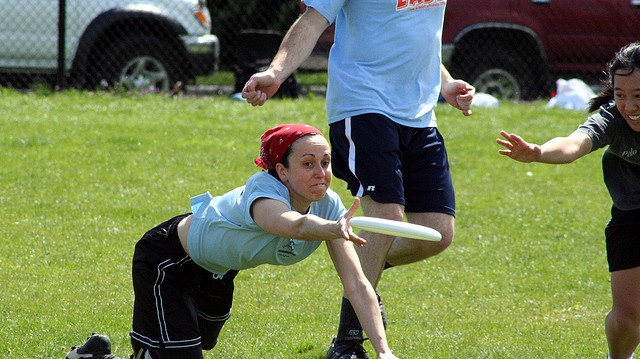Describe the objects in this image and their specific colors. I can see people in lightblue, black, darkgray, and gray tones, people in lightblue, black, and gray tones, truck in darkgray, black, and gray tones, truck in lightblue, black, maroon, purple, and darkgreen tones, and people in lightblue, black, maroon, and gray tones in this image. 